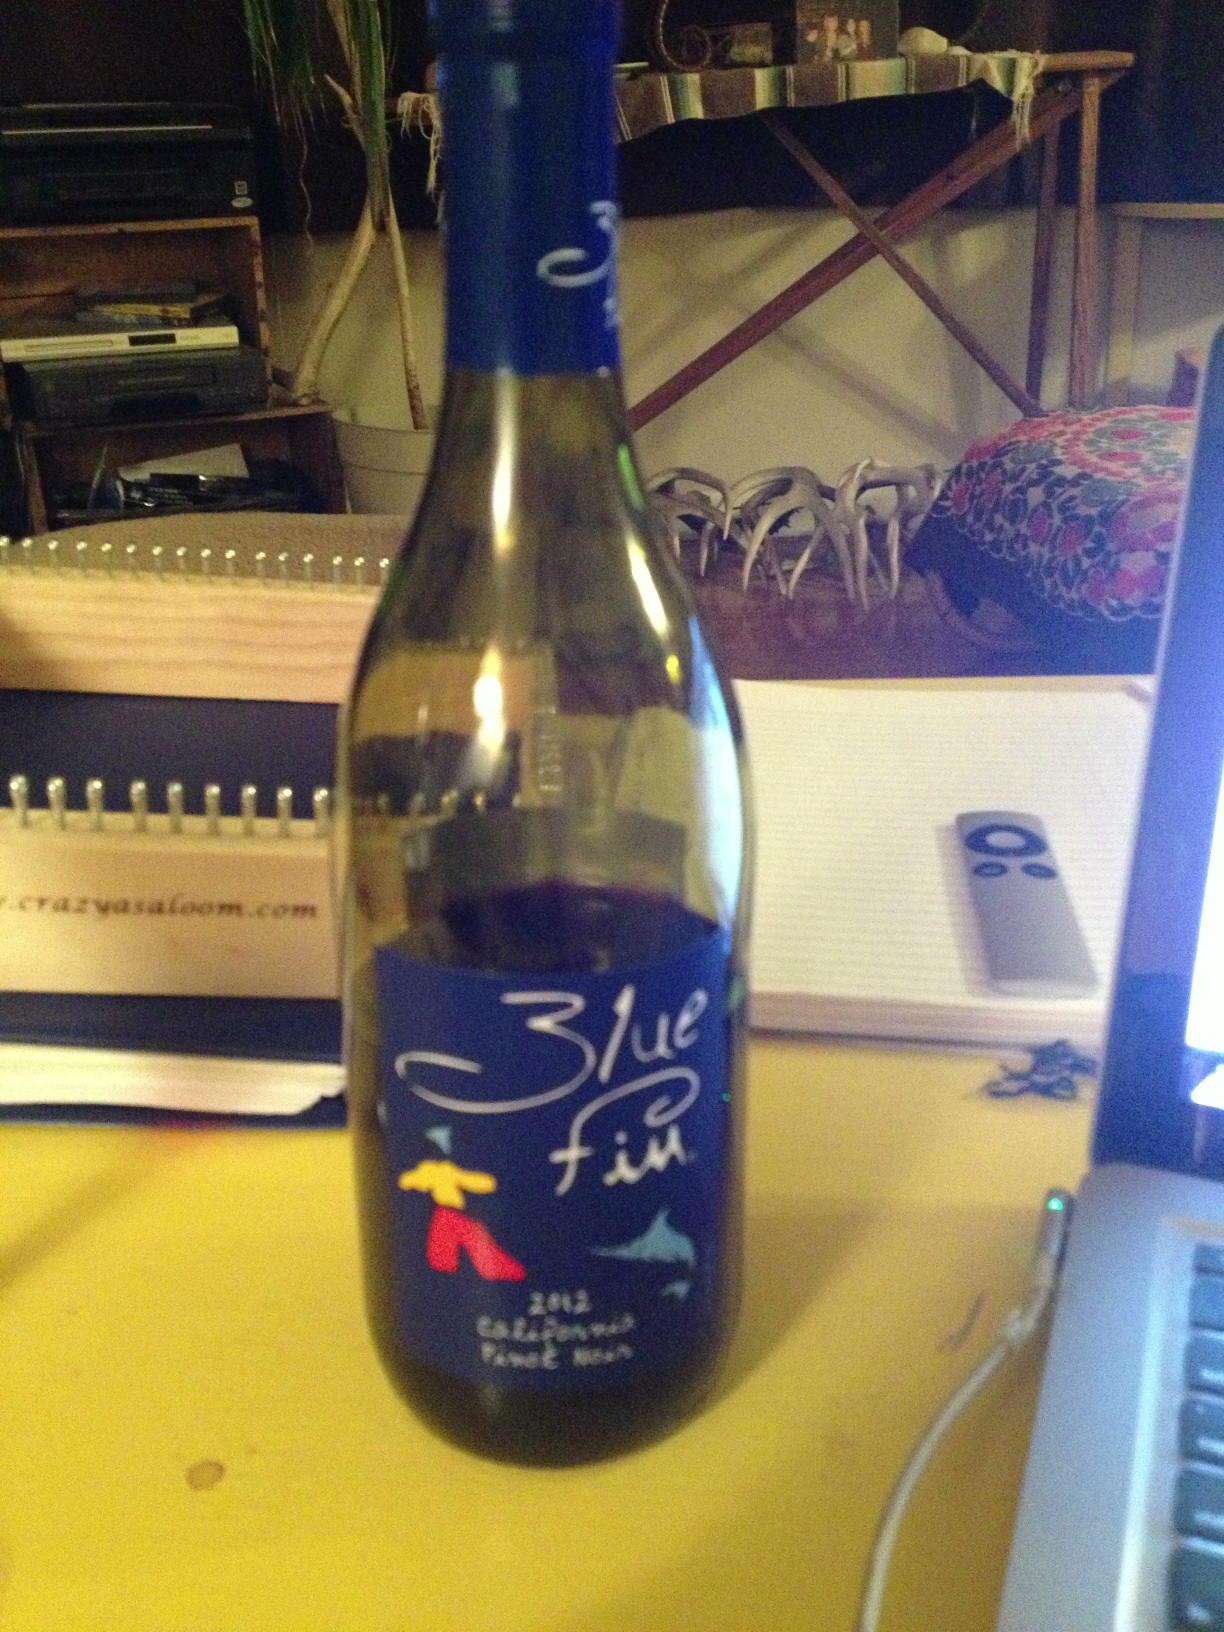What does the artwork on the bottle represent? The artwork features a stylized fish and a person in bold colors, likely representing the dynamic and vibrant qualities of the wine, as well as possibly invoking the maritime theme associated with the name 'Blue Fin.' 